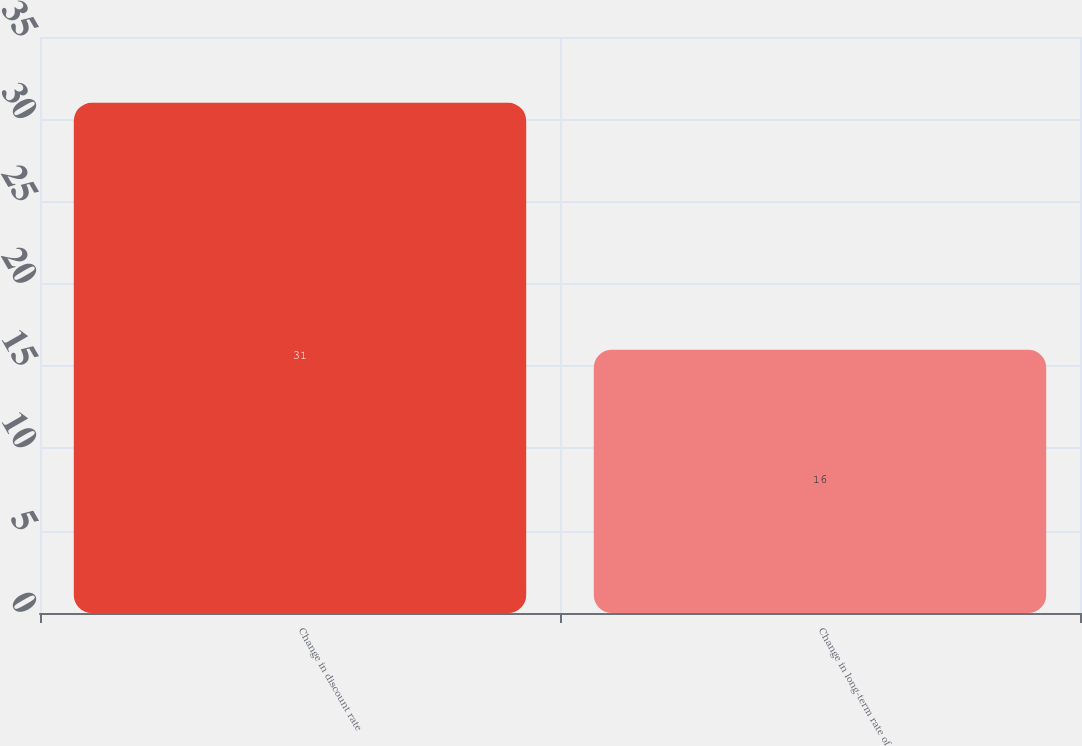Convert chart to OTSL. <chart><loc_0><loc_0><loc_500><loc_500><bar_chart><fcel>Change in discount rate<fcel>Change in long-term rate of<nl><fcel>31<fcel>16<nl></chart> 